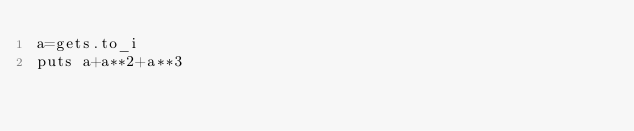Convert code to text. <code><loc_0><loc_0><loc_500><loc_500><_Ruby_>a=gets.to_i
puts a+a**2+a**3
</code> 